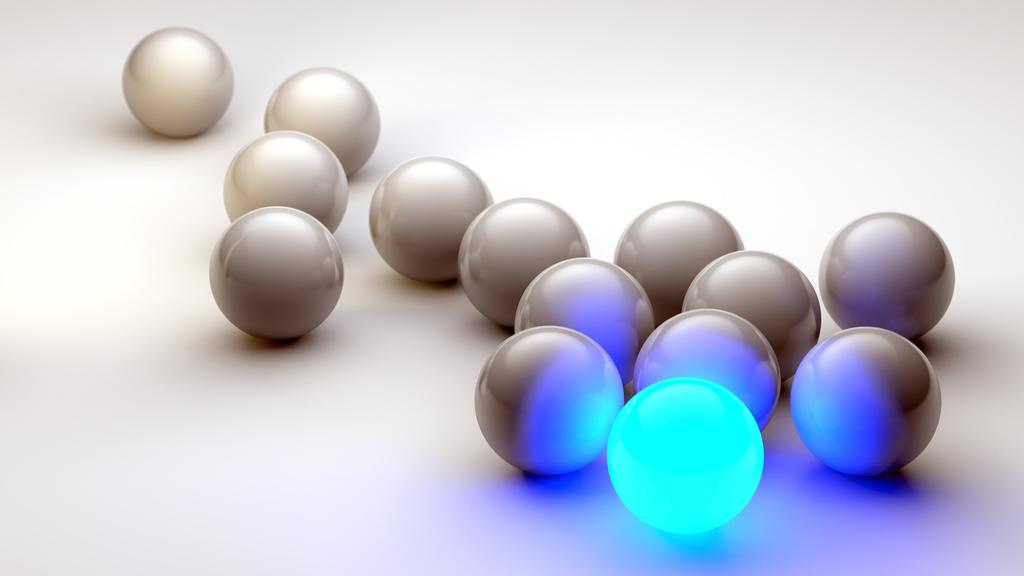What type of image is being described? The image appears to be graphical in nature. What objects can be seen in the image? There are balls in the image. Can you describe any specific characteristics of the balls? There is a light ball in the image. What type of plantation is depicted in the image? There is no plantation present in the image; it is a graphical image with balls. Can you tell me how many lawyers are visible in the image? There are no lawyers present in the image. 